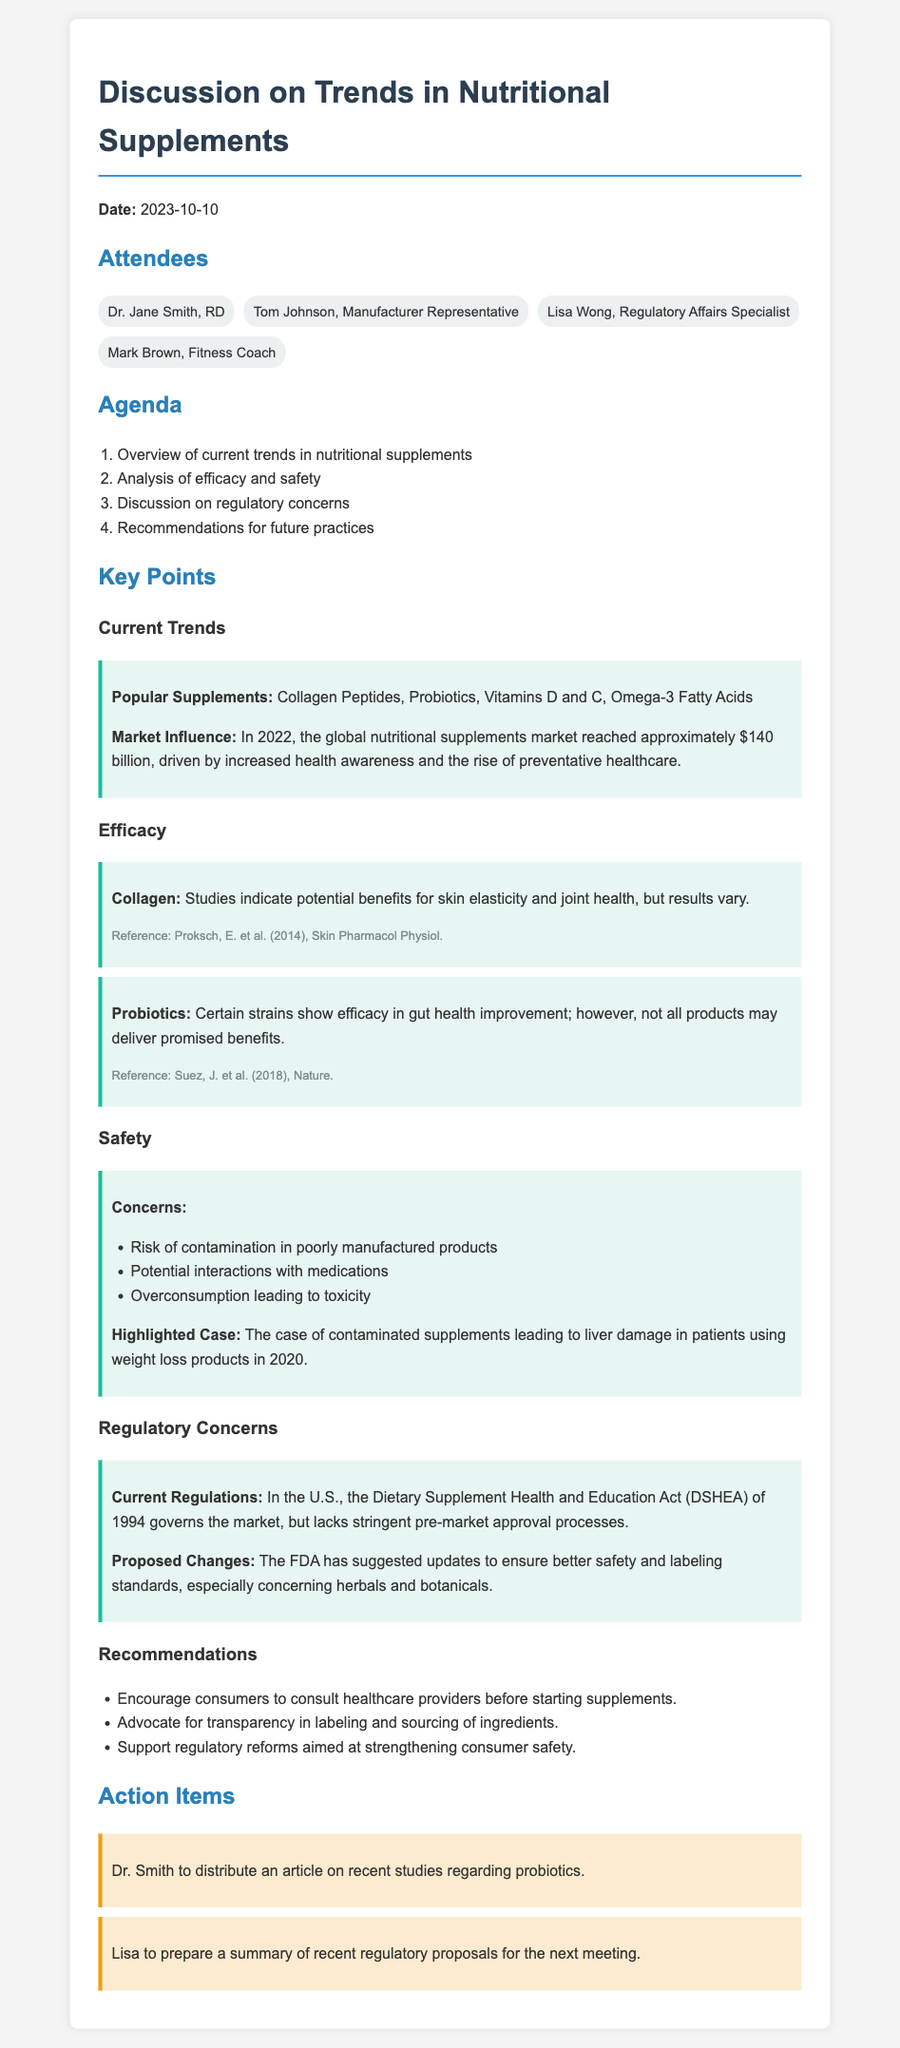What date was the meeting held? The date of the meeting is clearly stated at the beginning of the document.
Answer: 2023-10-10 Who were the attendees of the meeting? The attendees are listed in a section dedicated to them, showcasing each person's title or role.
Answer: Dr. Jane Smith, Tom Johnson, Lisa Wong, Mark Brown What are some popular supplements mentioned in the discussion? The document outlines specific supplements under current trends.
Answer: Collagen Peptides, Probiotics, Vitamins D and C, Omega-3 Fatty Acids What main risk is associated with poorly manufactured supplements? The potential risks are listed under safety concerns, highlighting a specific risk.
Answer: Contamination What act governs the nutritional supplement market in the U.S.? The document cites a specific act related to regulations concerning dietary supplements.
Answer: Dietary Supplement Health and Education Act (DSHEA) Which specific probiotics strain benefits were mentioned? The document highlights certain strains of probiotics under efficacy.
Answer: Gut health improvement What is one recommendation made during the meeting? Recommendations are listed clearly in their section for future practices.
Answer: Encourage consumers to consult healthcare providers before starting supplements What action item was assigned to Dr. Smith? An action item for Dr. Smith is noted explicitly in the document.
Answer: Distribute an article on recent studies regarding probiotics 